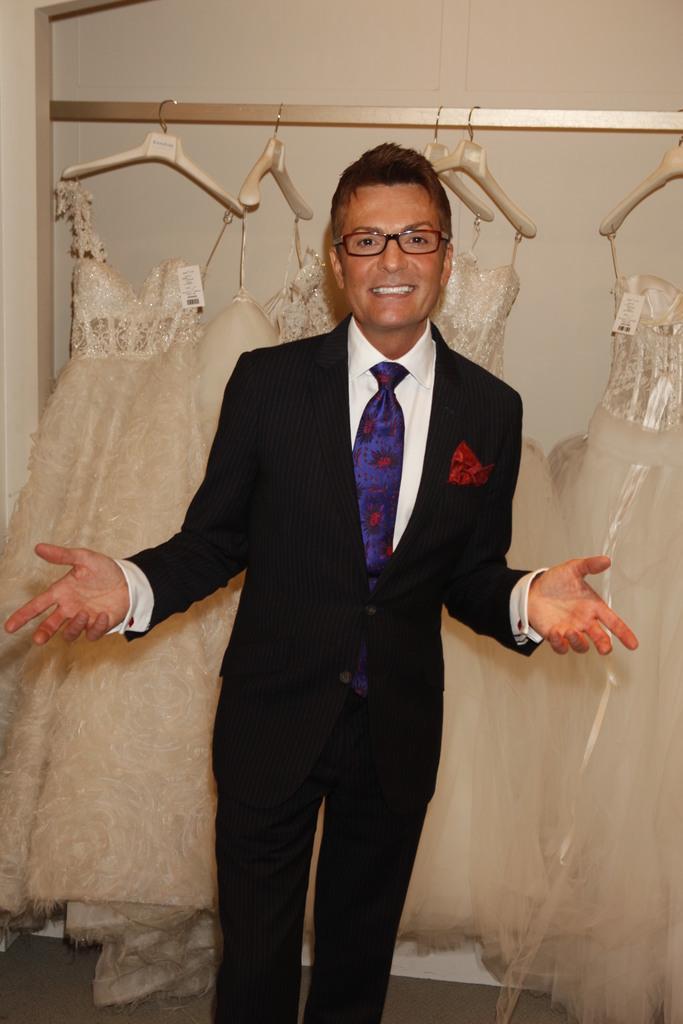Could you give a brief overview of what you see in this image? In this picture we can see a man, he is smiling and he wore spectacles, in the background we can find few clothes and hangers. 